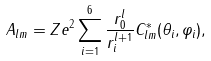Convert formula to latex. <formula><loc_0><loc_0><loc_500><loc_500>A _ { l m } = Z e ^ { 2 } \sum _ { i = 1 } ^ { 6 } \frac { r _ { 0 } ^ { l } } { r _ { i } ^ { l + 1 } } C _ { l m } ^ { * } ( \theta _ { i } , \varphi _ { i } ) ,</formula> 